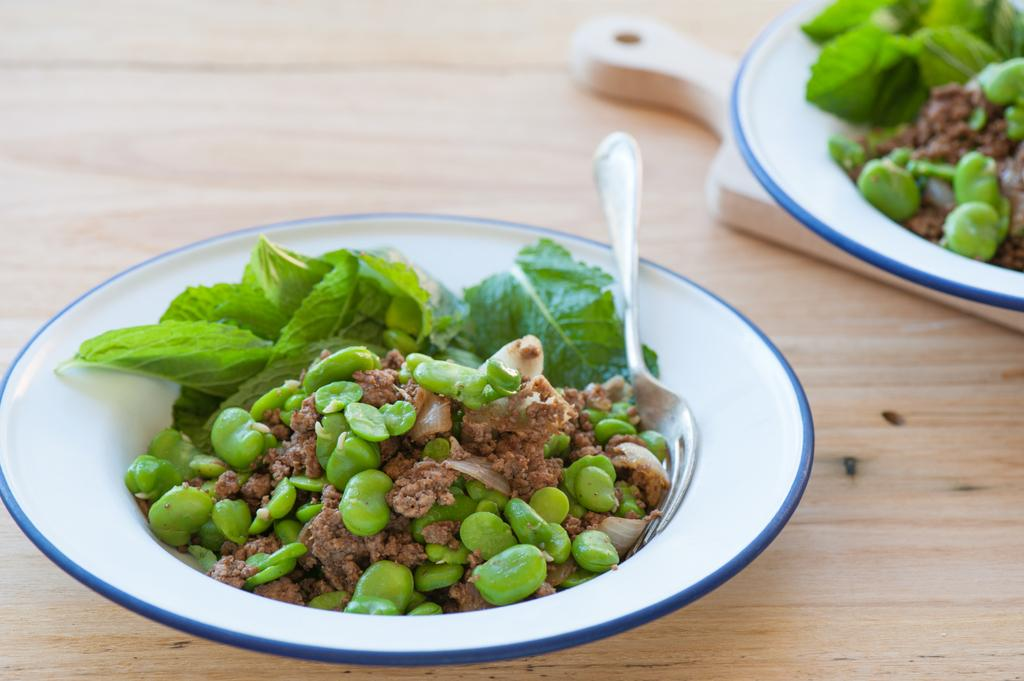What piece of furniture is present in the image? There is a table in the image. What is on the table? There are plates containing food and a tray on the table. What utensil is placed on the table? There is a fork placed on the table. Can you see the kitty's elbow in the image? There is no kitty present in the image, so it is not possible to see its elbow. 